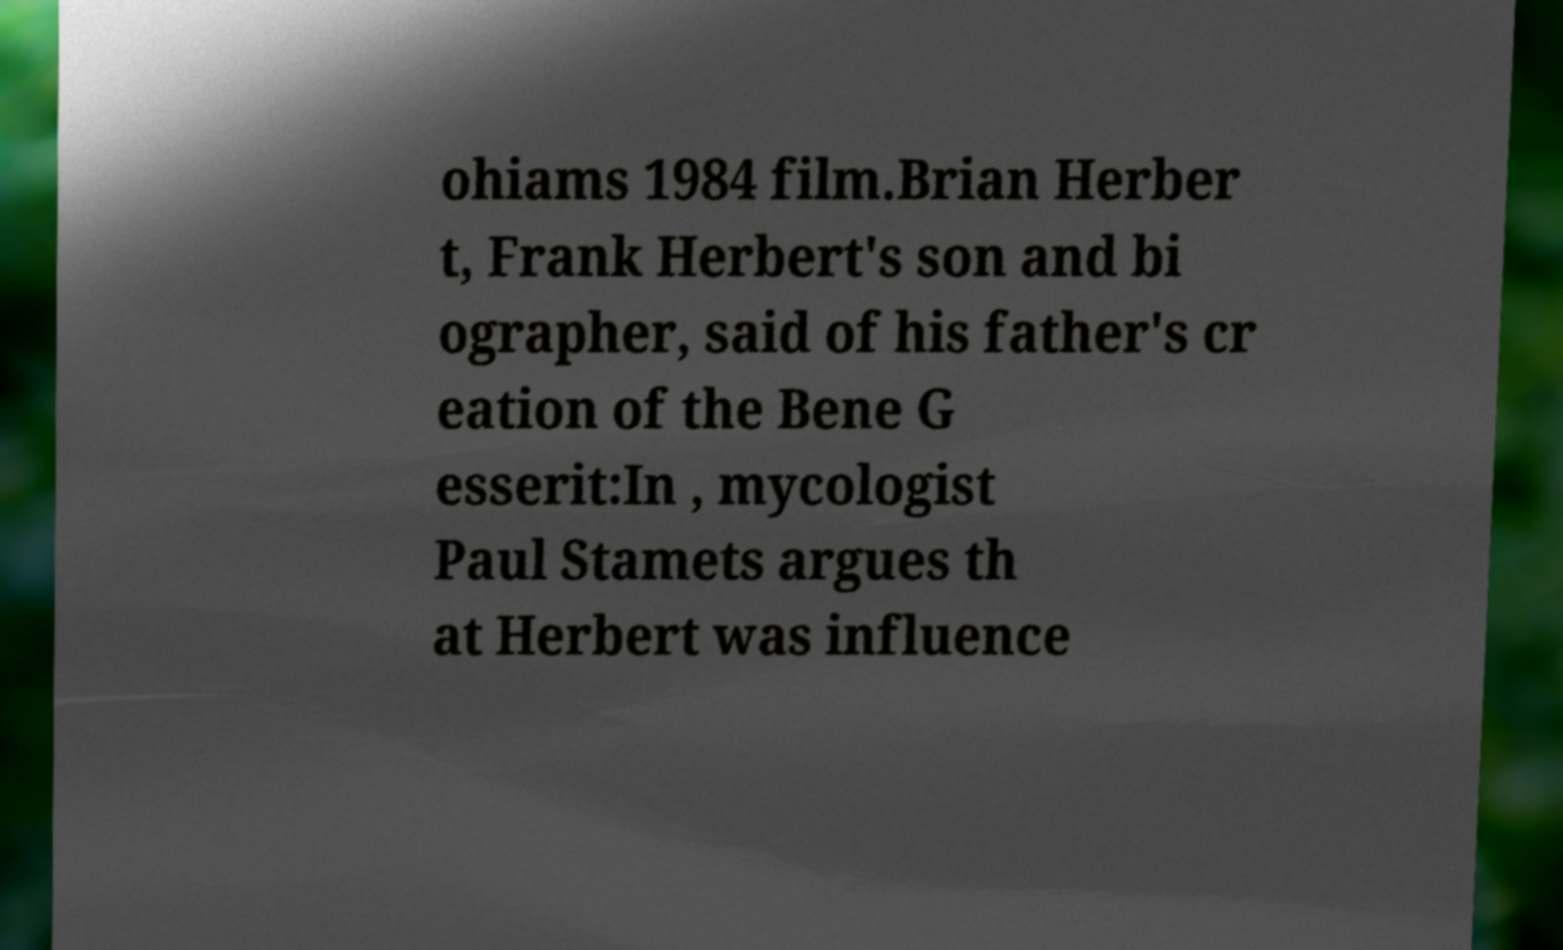For documentation purposes, I need the text within this image transcribed. Could you provide that? ohiams 1984 film.Brian Herber t, Frank Herbert's son and bi ographer, said of his father's cr eation of the Bene G esserit:In , mycologist Paul Stamets argues th at Herbert was influence 